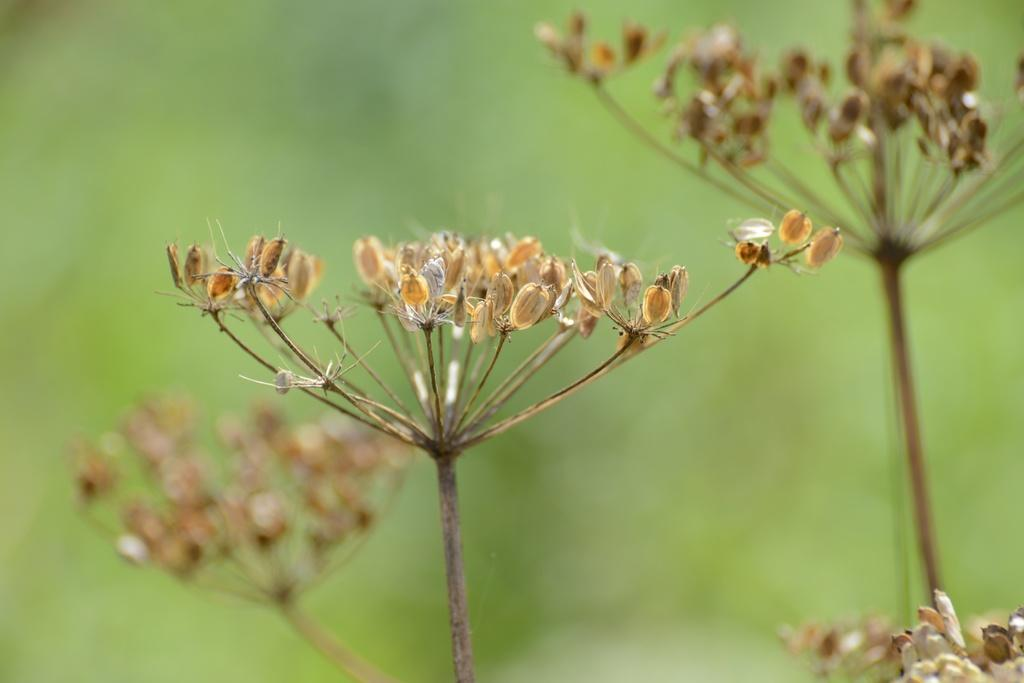What type of living organisms can be seen in the image? There are flowers in the image. Can you describe the background of the image? The background of the image is blurry. What type of agreement was reached between the flowers in the image? There is no indication in the image that the flowers are involved in any agreement or discussion. 